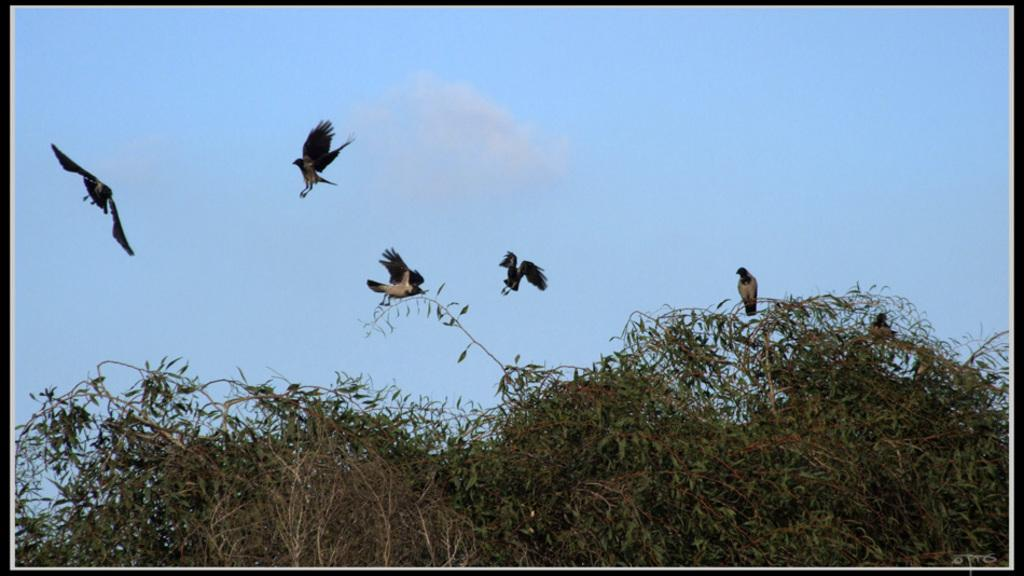What type of animals can be seen in the image? Birds can be seen in the image. What other living organisms are present in the image? There are plants in the image. What part of the natural environment is visible in the image? The sky is visible in the image. What can be observed in the sky? Clouds are present in the sky. Reasoning: Let' Let's think step by step in order to produce the conversation. We start by identifying the main subjects in the image, which are the birds and plants. Then, we expand the conversation to include the sky and clouds, which are also visible in the image. Each question is designed to elicit a specific detail about the image that is known from the provided facts. Absurd Question/Answer: What type of badge is the bird wearing in the image? There is no badge present on the birds in the image. What experience can be gained from observing the plants in the image? The image does not convey any specific experience related to the plants; it simply shows their presence. What type of chalk is the bird using to draw in the image? There is no chalk or drawing activity present in the image. 